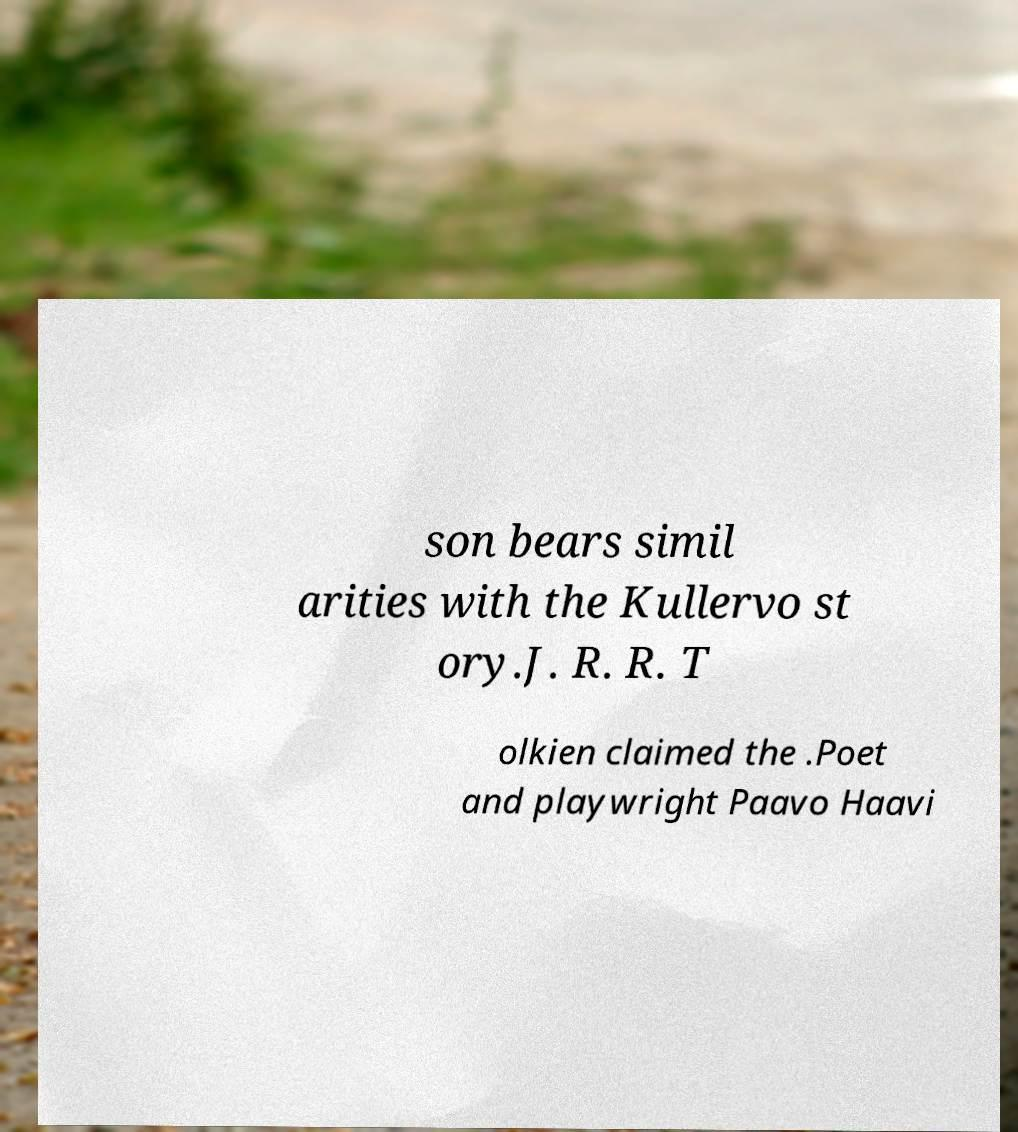Could you extract and type out the text from this image? son bears simil arities with the Kullervo st ory.J. R. R. T olkien claimed the .Poet and playwright Paavo Haavi 